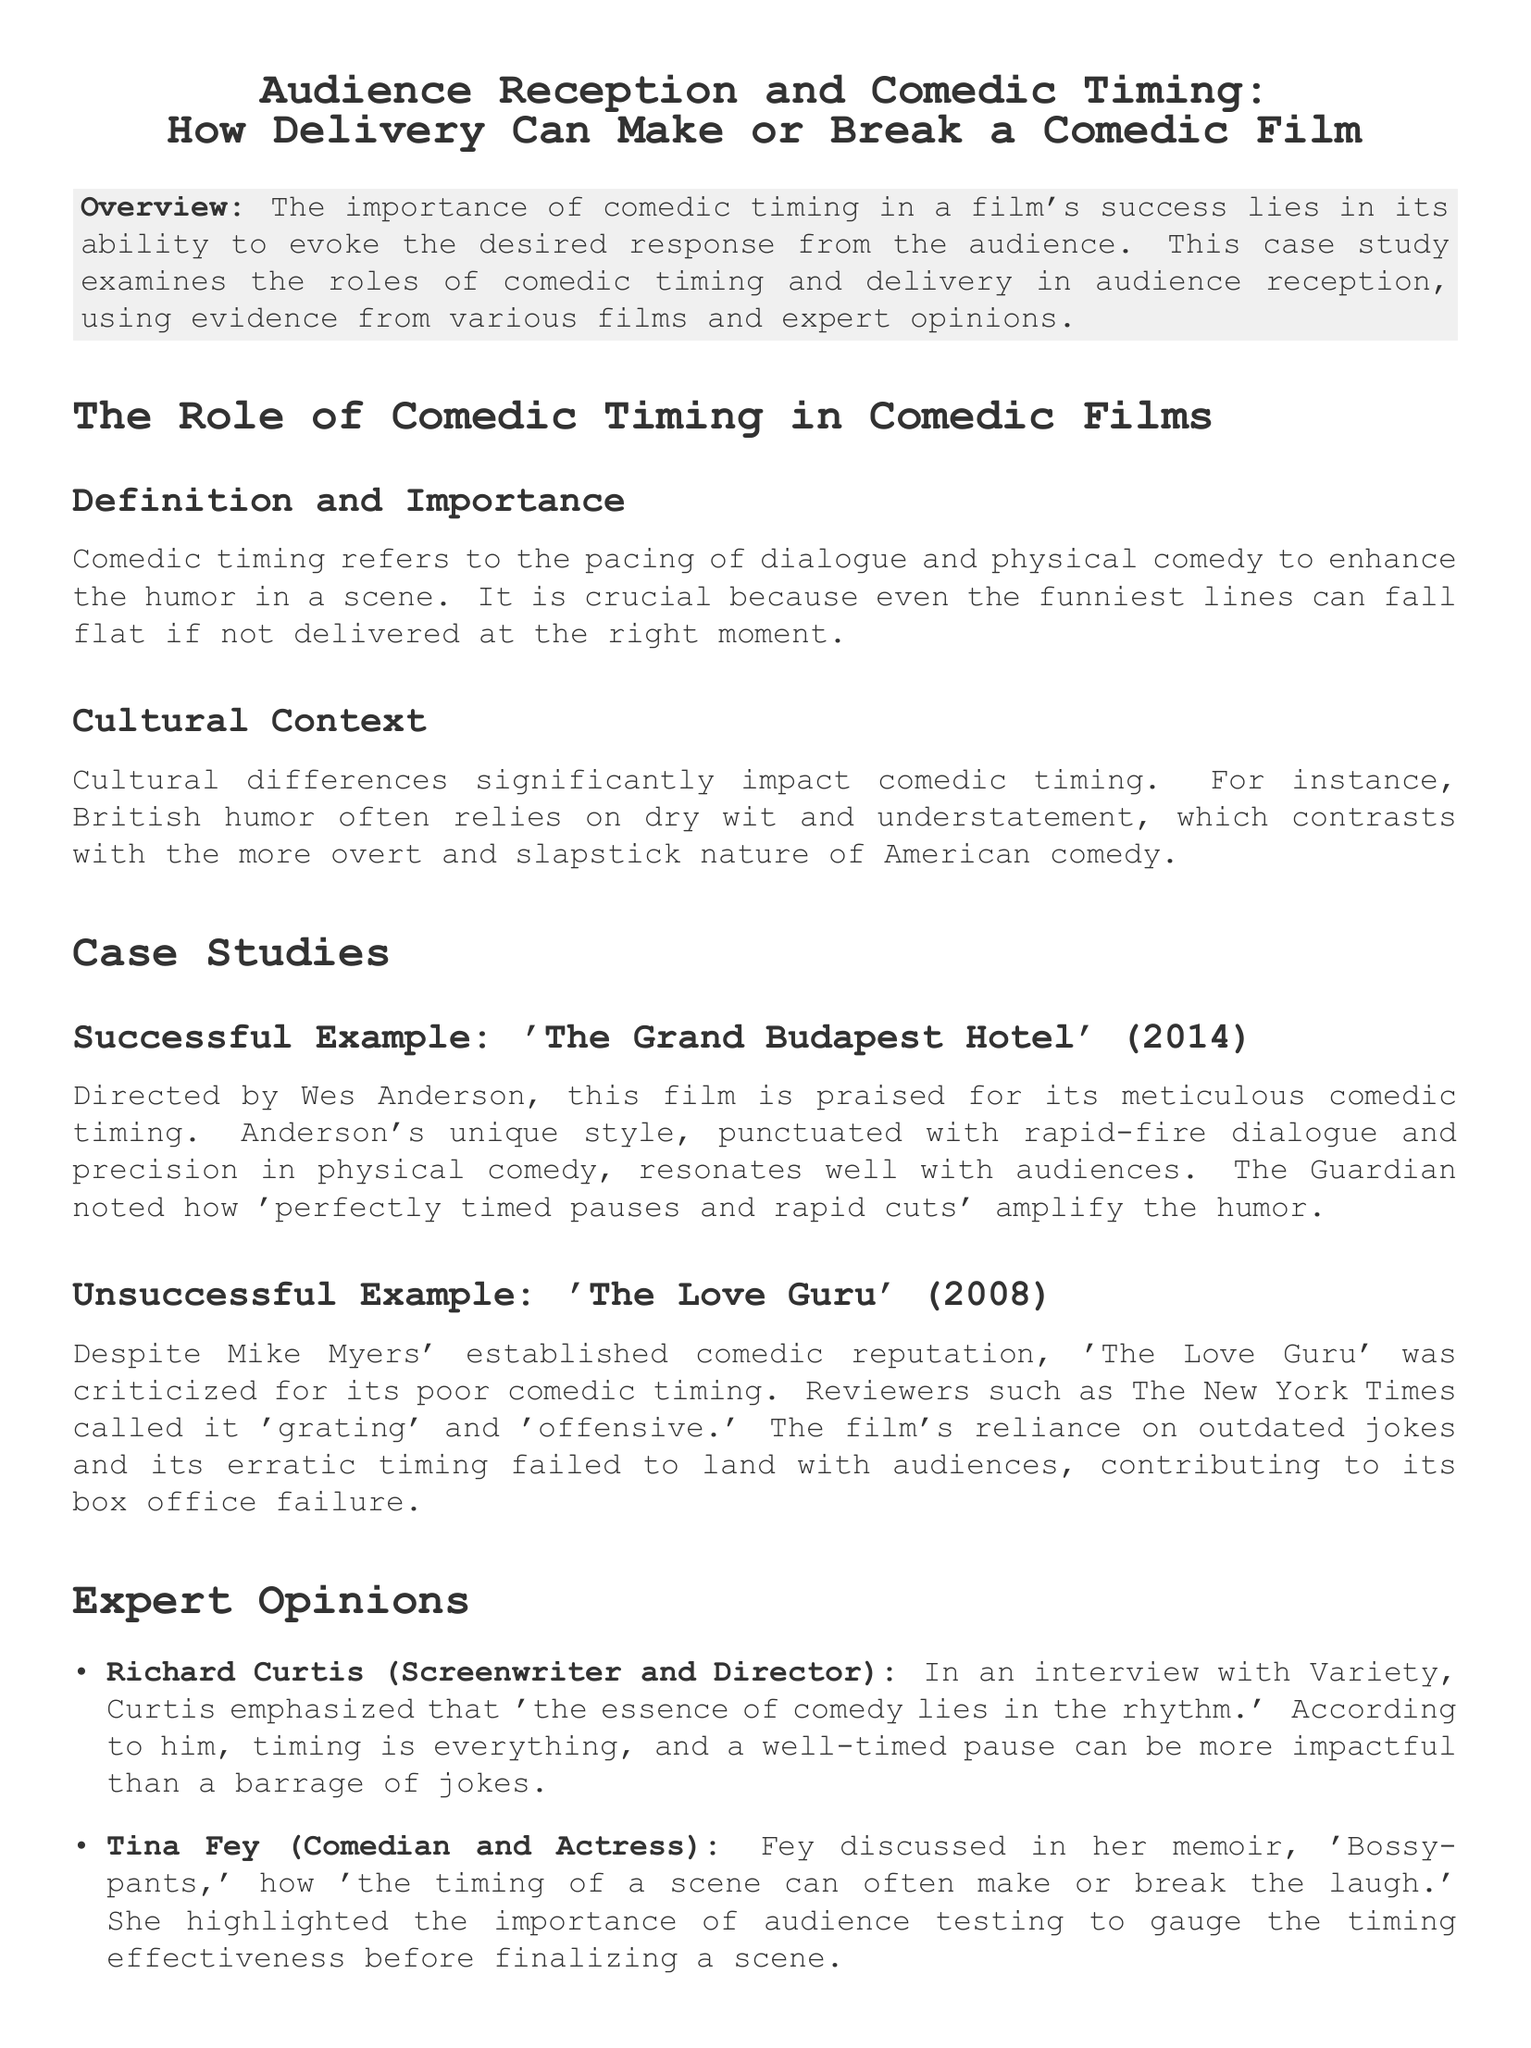What is the title of the case study? The title is found at the beginning of the document, specifying the focus of the study.
Answer: Audience Reception and Comedic Timing: How Delivery Can Make or Break a Comedic Film Who directed 'The Grand Budapest Hotel'? The director's name is mentioned in the successful example section of the case study.
Answer: Wes Anderson What was a criticism of 'The Love Guru'? The criticism is noted in the unsuccessful example section, specifically related to comedic timing.
Answer: Poor comedic timing Which publication noted the comedic timing in 'The Grand Budapest Hotel'? The publication is referenced in the successful example section discussing audience reception.
Answer: The Guardian What does Richard Curtis emphasize as crucial in comedy? This opinion is provided in the expert opinions section of the document.
Answer: Rhythm Which comedian discussed the timing effectiveness in her memoir? The name is found in the expert opinions section, where her insights are shared.
Answer: Tina Fey What year was 'The Love Guru' released? The release year is specified in the unsuccessful example section of the case study.
Answer: 2008 What does the conclusion emphasize as essential for comedic films? The conclusion summarizes the case study's findings regarding what influences film success.
Answer: Comedic timing 